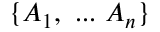Convert formula to latex. <formula><loc_0><loc_0><loc_500><loc_500>\{ A _ { 1 } , \dots A _ { n } \}</formula> 